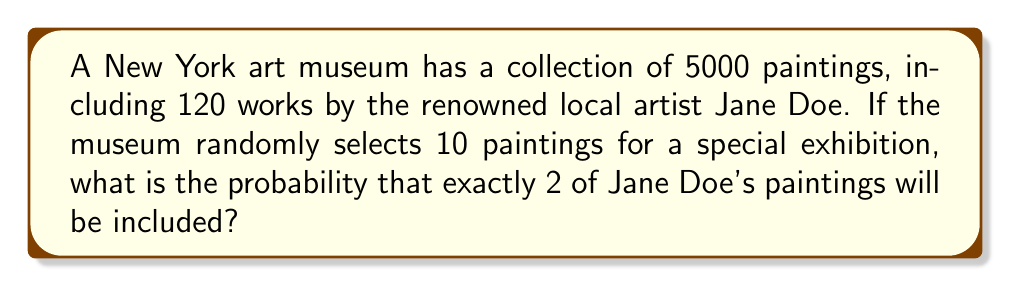What is the answer to this math problem? To solve this problem, we'll use the hypergeometric distribution, which is appropriate for sampling without replacement from a finite population.

1) First, let's identify the parameters:
   N = 5000 (total number of paintings)
   K = 120 (number of Jane Doe's paintings)
   n = 10 (number of paintings selected for exhibition)
   k = 2 (number of Jane Doe's paintings we want in the selection)

2) The probability mass function for the hypergeometric distribution is:

   $$P(X=k) = \frac{\binom{K}{k} \binom{N-K}{n-k}}{\binom{N}{n}}$$

3) Let's calculate each part:

   $\binom{K}{k} = \binom{120}{2} = 7140$
   
   $\binom{N-K}{n-k} = \binom{4880}{8} = 487,635,036,020$
   
   $\binom{N}{n} = \binom{5000}{10} = 2,755,647,693,770,342,400$

4) Now, let's substitute these values into our equation:

   $$P(X=2) = \frac{7140 \cdot 487,635,036,020}{2,755,647,693,770,342,400}$$

5) Simplifying:

   $$P(X=2) = \frac{3,481,714,157,182,800}{2,755,647,693,770,342,400} \approx 0.001263$$

Therefore, the probability of selecting exactly 2 of Jane Doe's paintings is approximately 0.001263 or about 0.1263%.
Answer: $0.001263$ 